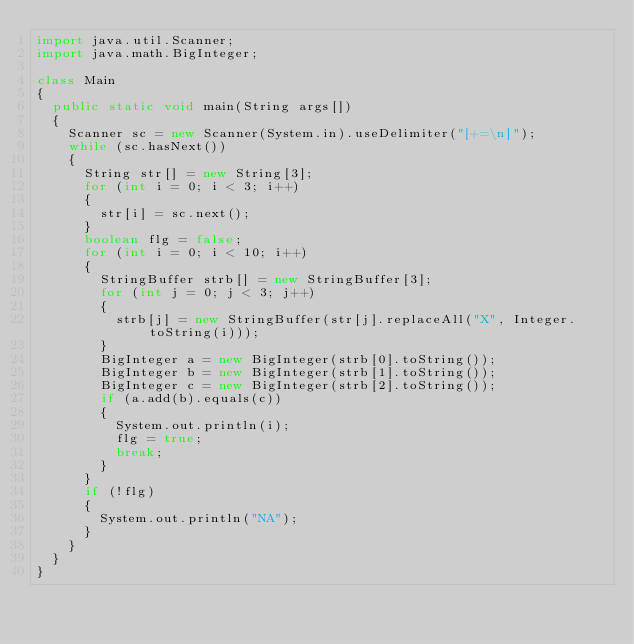<code> <loc_0><loc_0><loc_500><loc_500><_Java_>import java.util.Scanner;
import java.math.BigInteger;

class Main
{
	public static void main(String args[])
	{
		Scanner sc = new Scanner(System.in).useDelimiter("[+=\n]");
		while (sc.hasNext())
		{
			String str[] = new String[3];
			for (int i = 0; i < 3; i++)
			{
				str[i] = sc.next();
			}
			boolean flg = false;
			for (int i = 0; i < 10; i++)
			{
				StringBuffer strb[] = new StringBuffer[3];
				for (int j = 0; j < 3; j++)
				{
					strb[j] = new StringBuffer(str[j].replaceAll("X", Integer.toString(i)));
				}
				BigInteger a = new BigInteger(strb[0].toString());
				BigInteger b = new BigInteger(strb[1].toString());
				BigInteger c = new BigInteger(strb[2].toString());
				if (a.add(b).equals(c))
				{
					System.out.println(i);
					flg = true;
					break;
				}
			}
			if (!flg)
			{
				System.out.println("NA");
			}
		}
	}
}</code> 